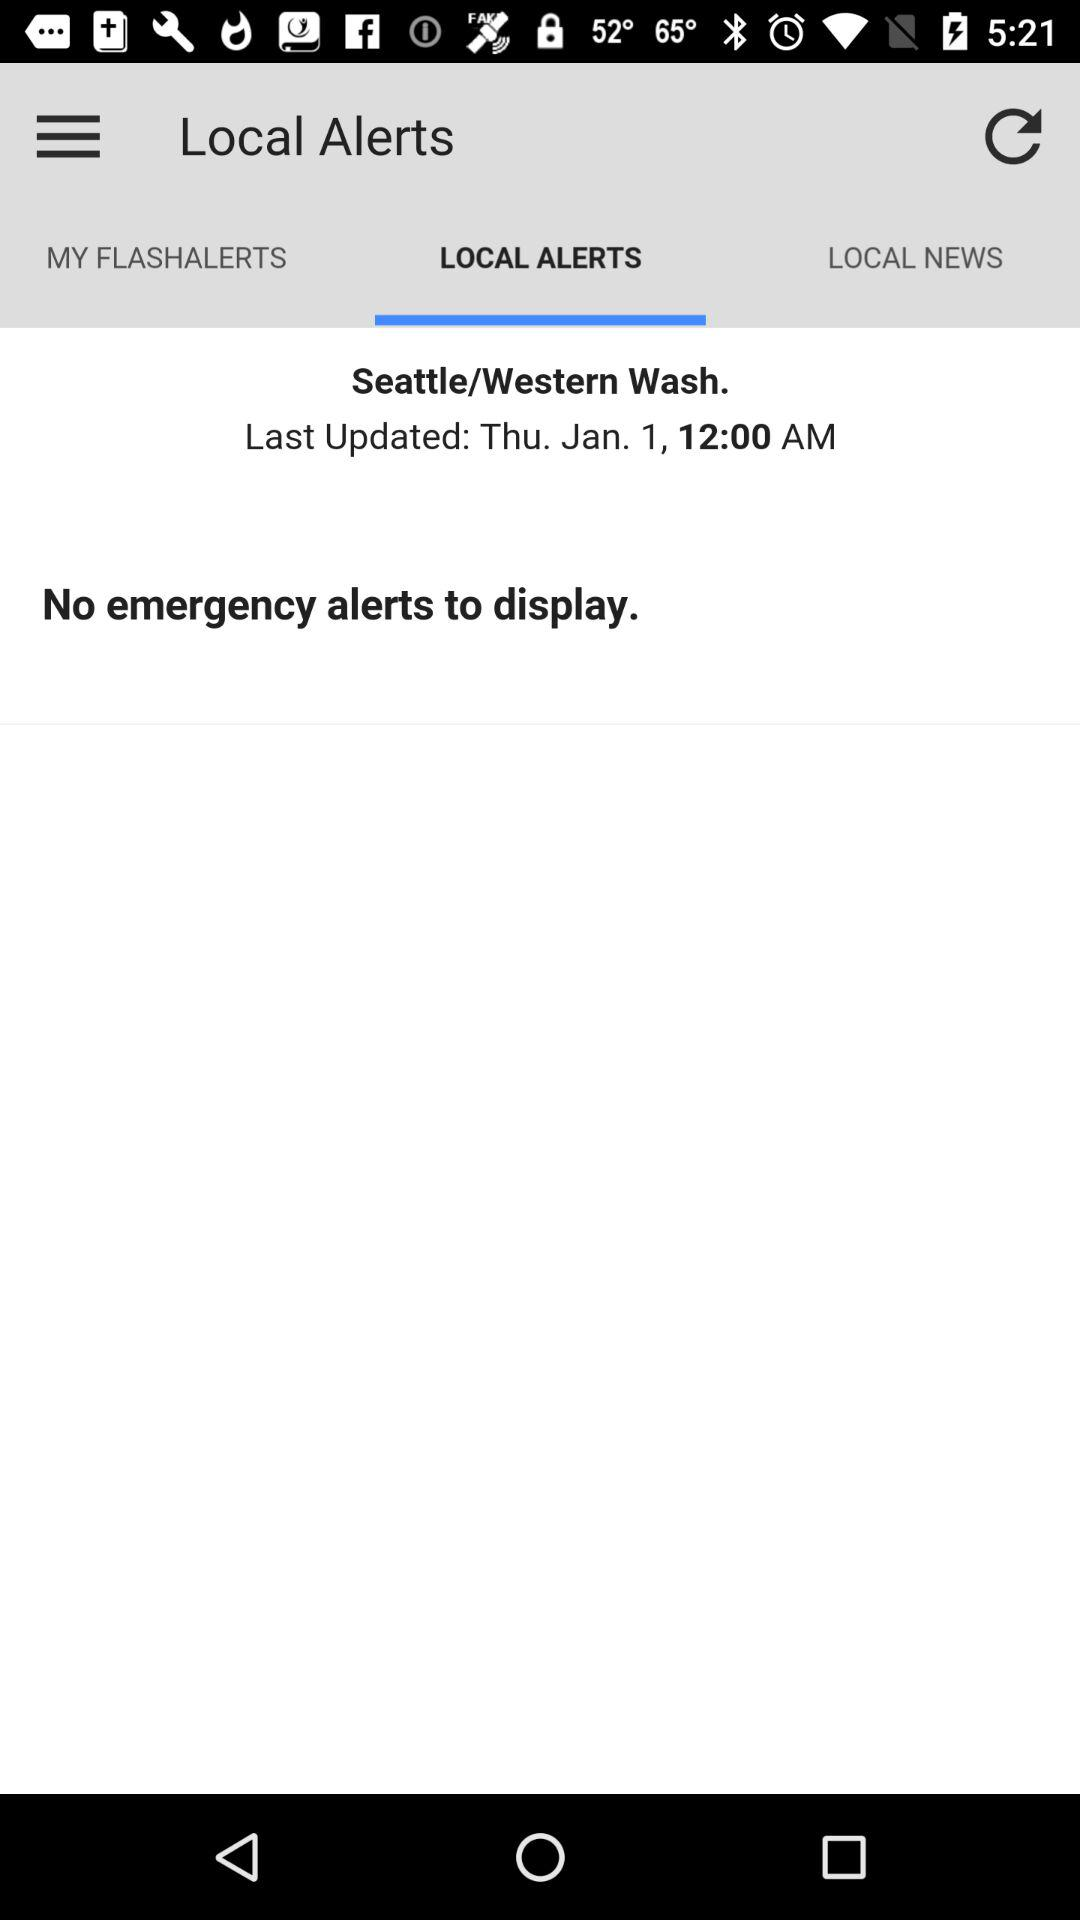How many alerts are displayed?
Answer the question using a single word or phrase. 0 